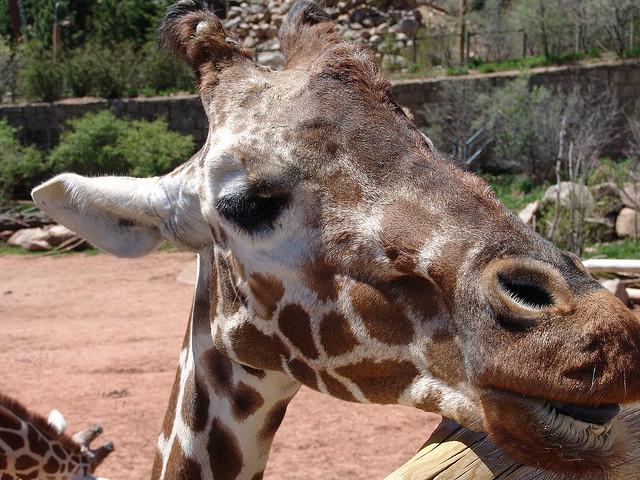What is this animal?
Give a very brief answer. Giraffe. What is the fence made of?
Be succinct. Wood. How many giraffes are there?
Write a very short answer. 2. What kind of an animal is this?
Short answer required. Giraffe. What color are the animal's spots?
Answer briefly. Brown. What material is the rail made from in this picture?
Answer briefly. Wood. How many people are in this picture?
Be succinct. 0. Is this leaf eater wild?
Keep it brief. No. How many rocks in the background?
Give a very brief answer. 5. 